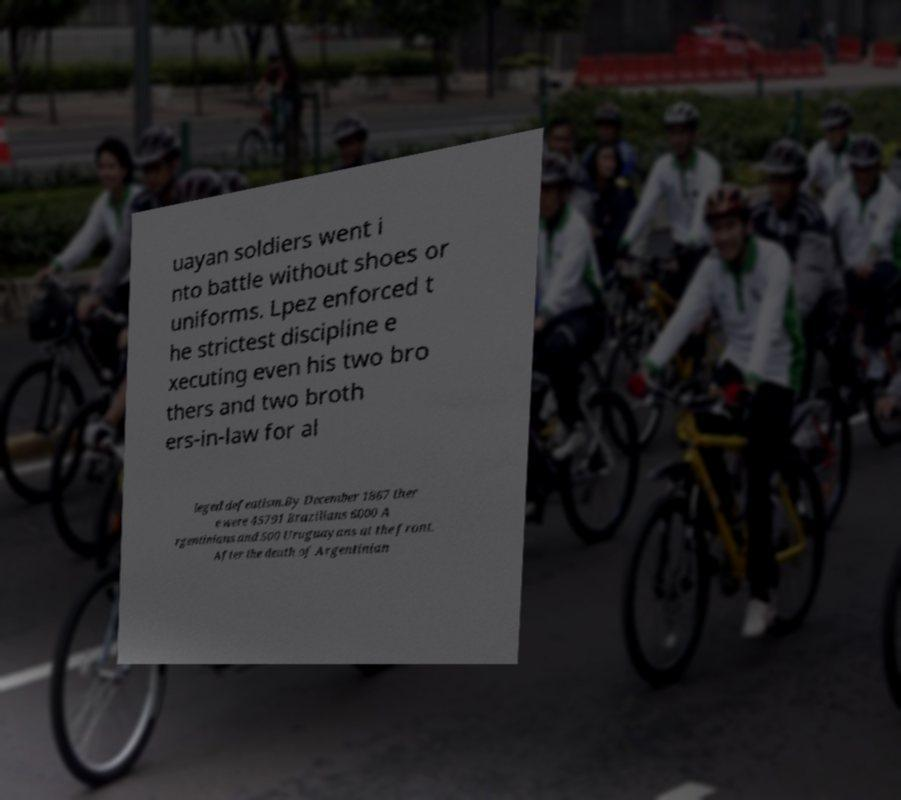There's text embedded in this image that I need extracted. Can you transcribe it verbatim? uayan soldiers went i nto battle without shoes or uniforms. Lpez enforced t he strictest discipline e xecuting even his two bro thers and two broth ers-in-law for al leged defeatism.By December 1867 ther e were 45791 Brazilians 6000 A rgentinians and 500 Uruguayans at the front. After the death of Argentinian 